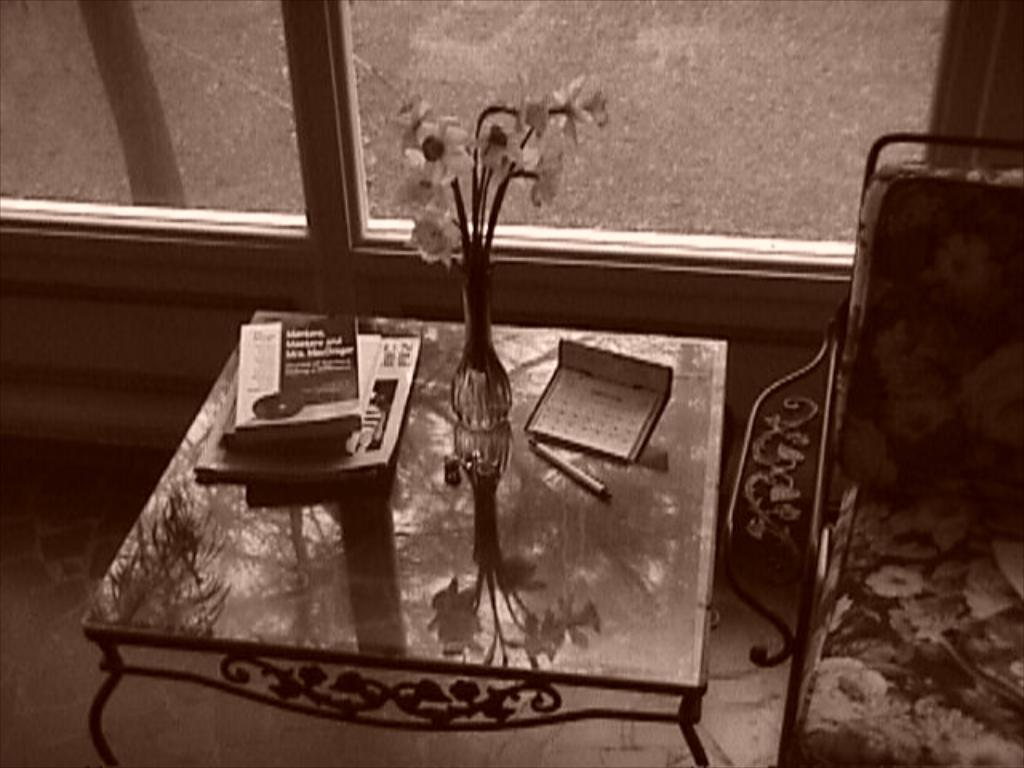What piece of furniture is present in the image? There is a table in the image. What is placed on the table? A flower vase, a group of books, and a pen are placed on the table. Is there any seating arrangement near the table? Yes, there is a chair to the right side of the table. What can be seen in the background of the image? There is a window visible in the background. What type of sofa is being used for teaching in the image? There is no sofa or teaching activity present in the image. What color is the sky in the image? The provided facts do not mention the color of the sky, as the focus is on the table, its contents, and the chair. 